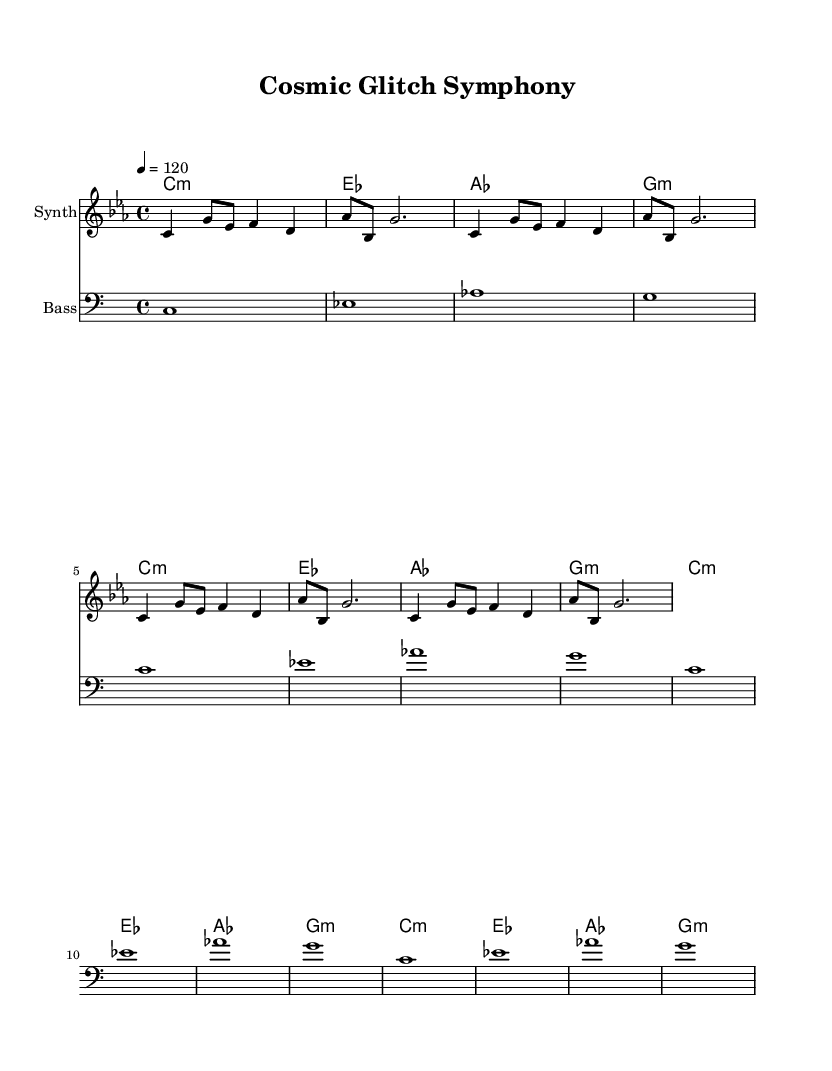What is the key signature of this music? The key signature shown in the music indicates C minor, which has three flats: B flat, E flat, and A flat.
Answer: C minor What is the time signature of this piece? The time signature written at the beginning of the music is 4/4, indicating four beats per measure, with a quarter note receiving one beat.
Answer: 4/4 What tempo is indicated for this composition? The tempo marking indicates a speed of quarter note equals 120 beats per minute, meaning it should be played quite briskly.
Answer: 120 How many measures are there in the melody? The melody consists of 12 measures total, which includes the repeated sequences of the melody.
Answer: 12 What type of musical modes are used in the harmonies? The harmonies include the use of minor chords specifically, as indicated by the notation (for example, c1:m represents a C minor chord).
Answer: Minor What is the registration of the bass line? The bass line is written in the bass clef, indicating lower pitch sounds typically played by bass instruments to provide harmonic support.
Answer: Bass clef How many times is the main melody repeated? The main melody is repeated three times throughout the piece, as indicated by the repeat instruction and the phrasing in the music notation.
Answer: 3 